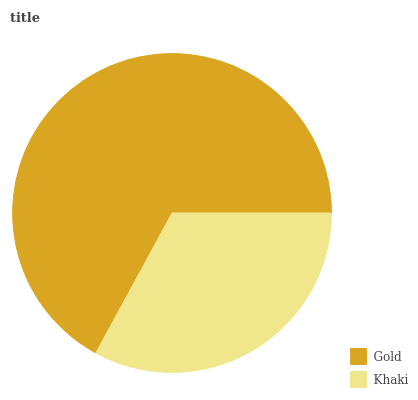Is Khaki the minimum?
Answer yes or no. Yes. Is Gold the maximum?
Answer yes or no. Yes. Is Khaki the maximum?
Answer yes or no. No. Is Gold greater than Khaki?
Answer yes or no. Yes. Is Khaki less than Gold?
Answer yes or no. Yes. Is Khaki greater than Gold?
Answer yes or no. No. Is Gold less than Khaki?
Answer yes or no. No. Is Gold the high median?
Answer yes or no. Yes. Is Khaki the low median?
Answer yes or no. Yes. Is Khaki the high median?
Answer yes or no. No. Is Gold the low median?
Answer yes or no. No. 